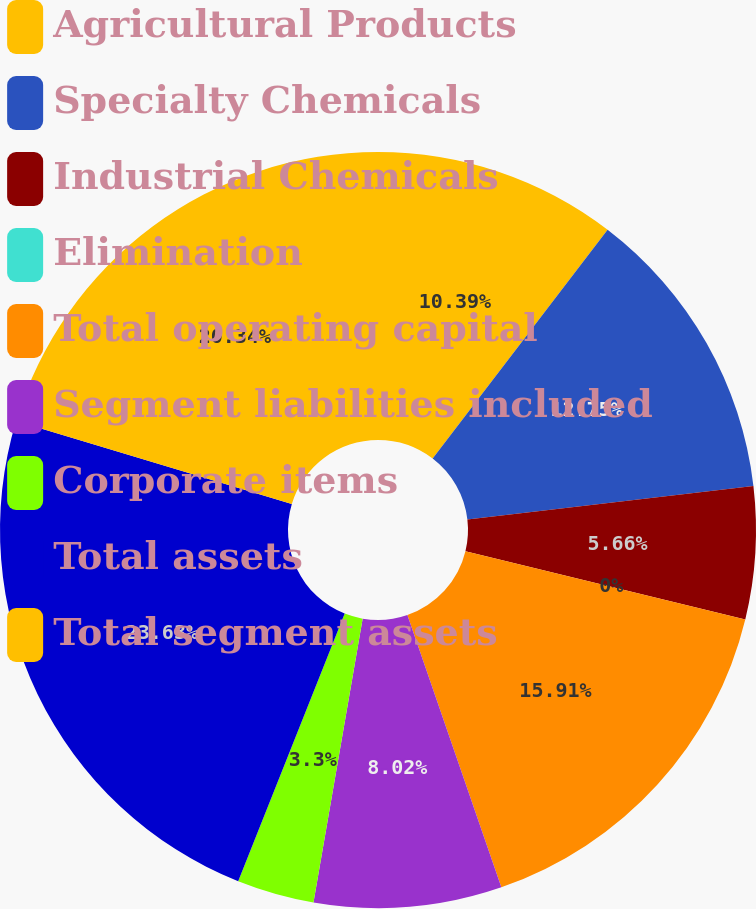Convert chart. <chart><loc_0><loc_0><loc_500><loc_500><pie_chart><fcel>Agricultural Products<fcel>Specialty Chemicals<fcel>Industrial Chemicals<fcel>Elimination<fcel>Total operating capital<fcel>Segment liabilities included<fcel>Corporate items<fcel>Total assets<fcel>Total segment assets<nl><fcel>10.39%<fcel>12.75%<fcel>5.66%<fcel>0.0%<fcel>15.91%<fcel>8.02%<fcel>3.3%<fcel>23.63%<fcel>20.34%<nl></chart> 